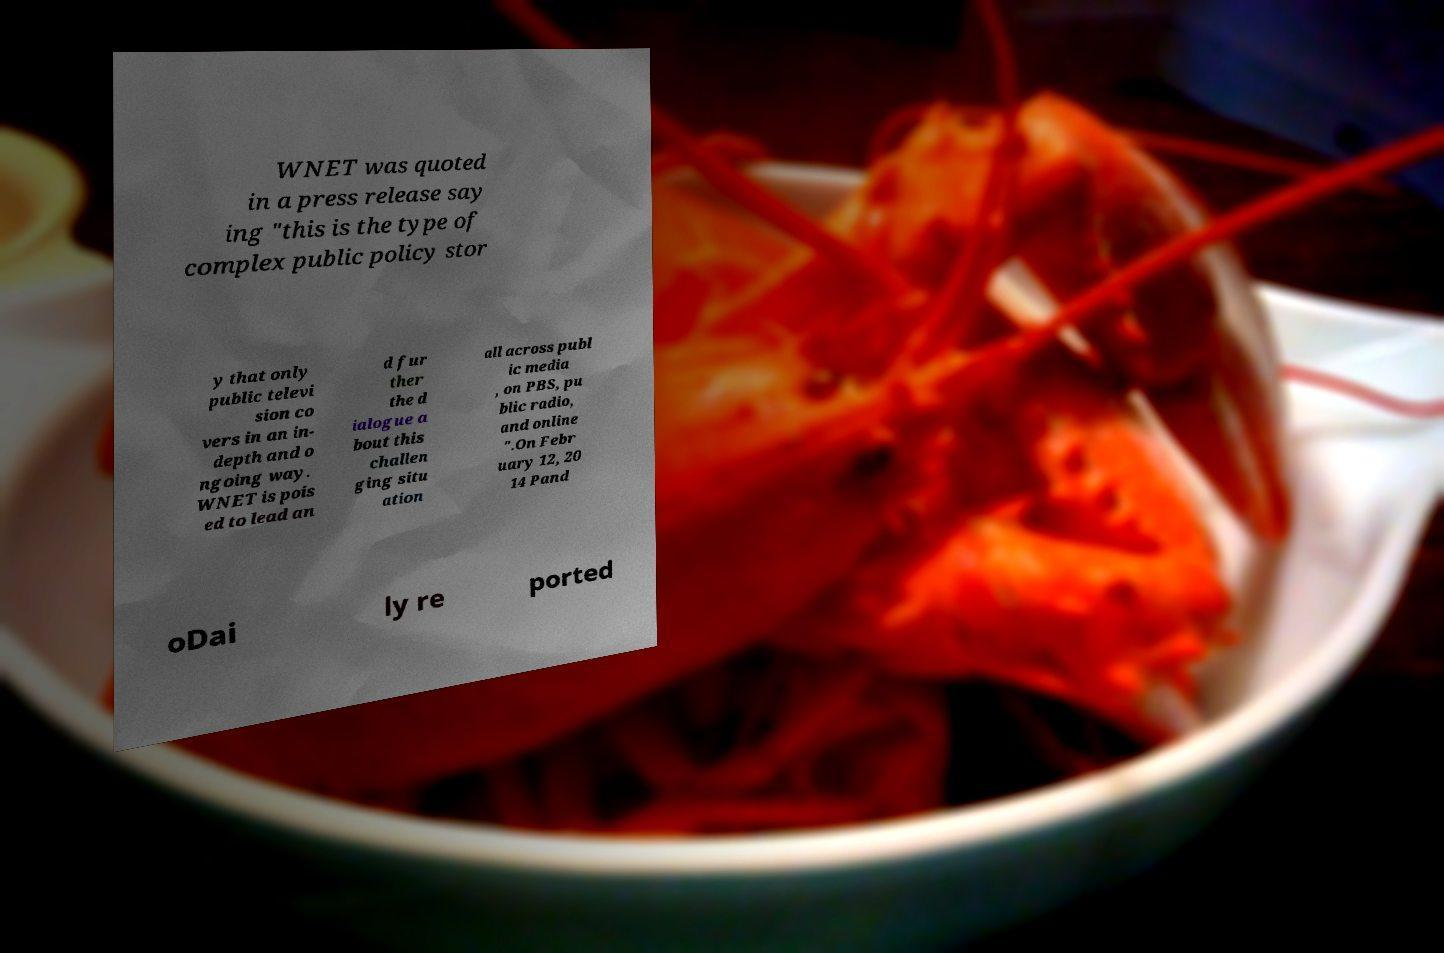Can you accurately transcribe the text from the provided image for me? WNET was quoted in a press release say ing "this is the type of complex public policy stor y that only public televi sion co vers in an in- depth and o ngoing way. WNET is pois ed to lead an d fur ther the d ialogue a bout this challen ging situ ation all across publ ic media , on PBS, pu blic radio, and online ".On Febr uary 12, 20 14 Pand oDai ly re ported 